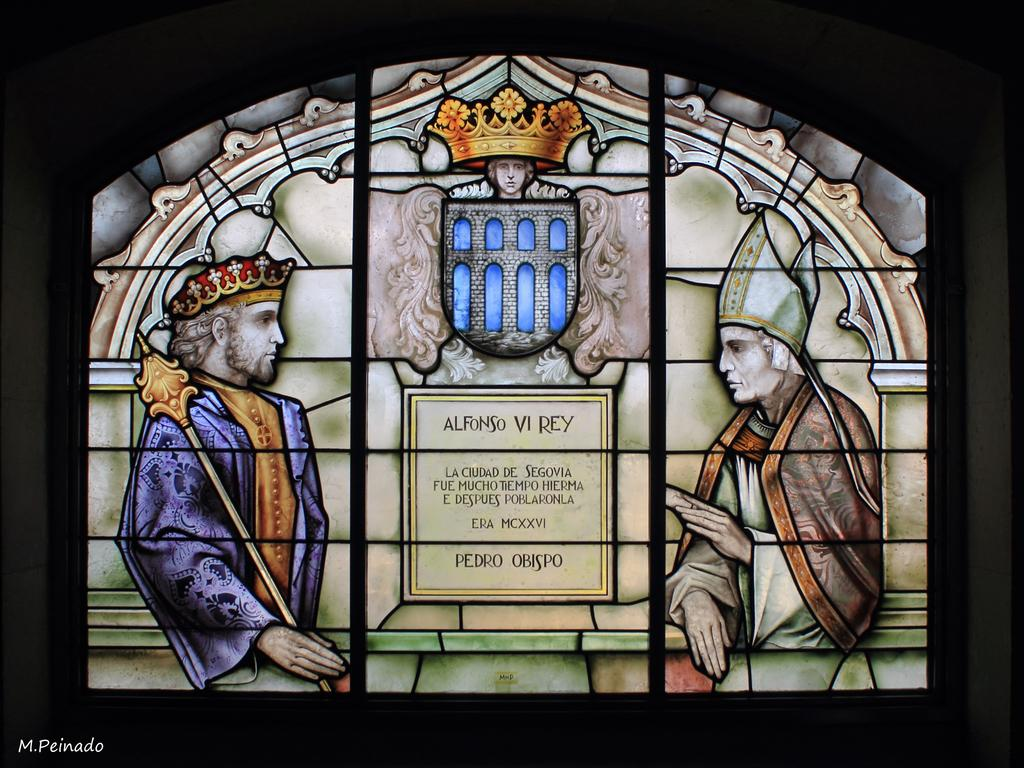What type of window is visible in the image? There is a tinted glass window in the image. What type of pest can be seen crawling on the window in the image? There is no pest visible on the window in the image. How many cows can be seen grazing outside the window in the image? There is no reference to cows or any grazing activity in the image. 